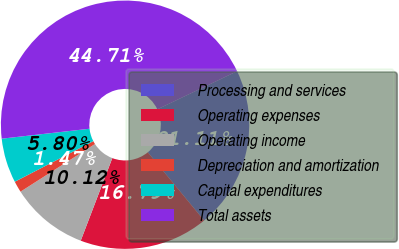<chart> <loc_0><loc_0><loc_500><loc_500><pie_chart><fcel>Processing and services<fcel>Operating expenses<fcel>Operating income<fcel>Depreciation and amortization<fcel>Capital expenditures<fcel>Total assets<nl><fcel>21.11%<fcel>16.79%<fcel>10.12%<fcel>1.47%<fcel>5.8%<fcel>44.71%<nl></chart> 